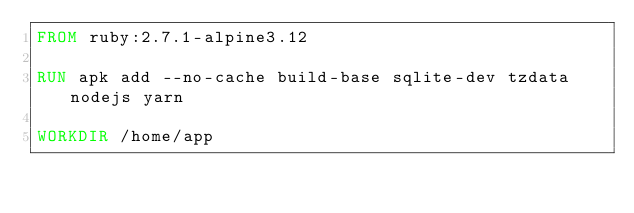<code> <loc_0><loc_0><loc_500><loc_500><_Dockerfile_>FROM ruby:2.7.1-alpine3.12

RUN apk add --no-cache build-base sqlite-dev tzdata nodejs yarn

WORKDIR /home/app
</code> 